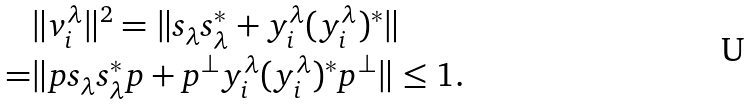<formula> <loc_0><loc_0><loc_500><loc_500>& \| v _ { i } ^ { \lambda } \| ^ { 2 } = \| s _ { \lambda } s _ { \lambda } ^ { * } + y _ { i } ^ { \lambda } ( y _ { i } ^ { \lambda } ) ^ { * } \| \\ = & \| p s _ { \lambda } s _ { \lambda } ^ { * } p + p ^ { \bot } y _ { i } ^ { \lambda } ( y _ { i } ^ { \lambda } ) ^ { * } p ^ { \bot } \| \leq 1 .</formula> 